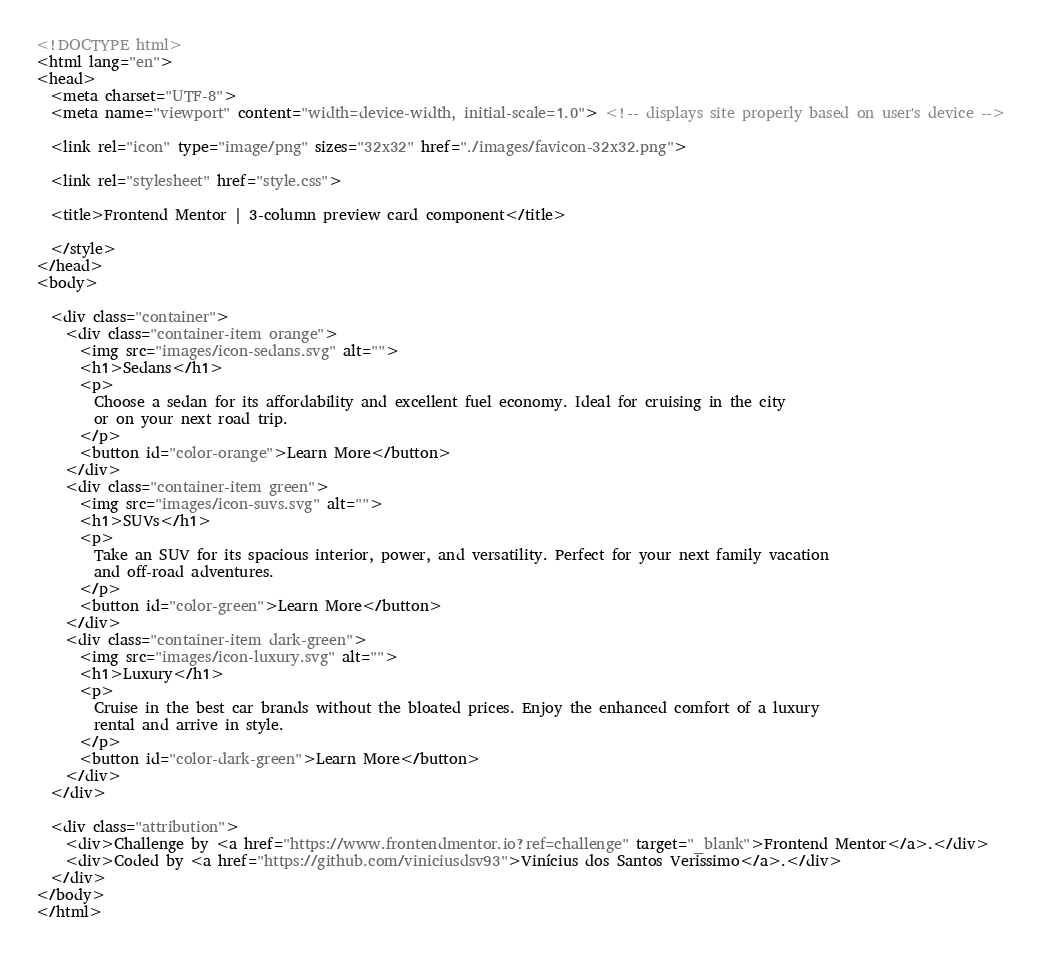<code> <loc_0><loc_0><loc_500><loc_500><_HTML_><!DOCTYPE html>
<html lang="en">
<head>
  <meta charset="UTF-8">
  <meta name="viewport" content="width=device-width, initial-scale=1.0"> <!-- displays site properly based on user's device -->

  <link rel="icon" type="image/png" sizes="32x32" href="./images/favicon-32x32.png">

  <link rel="stylesheet" href="style.css">
  
  <title>Frontend Mentor | 3-column preview card component</title>

  </style>
</head>
<body>
  
  <div class="container">
    <div class="container-item orange">
      <img src="images/icon-sedans.svg" alt="">
      <h1>Sedans</h1>
      <p>
        Choose a sedan for its affordability and excellent fuel economy. Ideal for cruising in the city
        or on your next road trip.
      </p>
      <button id="color-orange">Learn More</button>
    </div>
    <div class="container-item green">
      <img src="images/icon-suvs.svg" alt="">
      <h1>SUVs</h1>
      <p>
        Take an SUV for its spacious interior, power, and versatility. Perfect for your next family vacation
        and off-road adventures.
      </p>
      <button id="color-green">Learn More</button>
    </div>
    <div class="container-item dark-green">
      <img src="images/icon-luxury.svg" alt="">
      <h1>Luxury</h1>
      <p>
        Cruise in the best car brands without the bloated prices. Enjoy the enhanced comfort of a luxury
        rental and arrive in style.
      </p>
      <button id="color-dark-green">Learn More</button>
    </div>
  </div>
  
  <div class="attribution">
    <div>Challenge by <a href="https://www.frontendmentor.io?ref=challenge" target="_blank">Frontend Mentor</a>.</div>
    <div>Coded by <a href="https://github.com/viniciusdsv93">Vinícius dos Santos Verissimo</a>.</div>
  </div>
</body>
</html></code> 